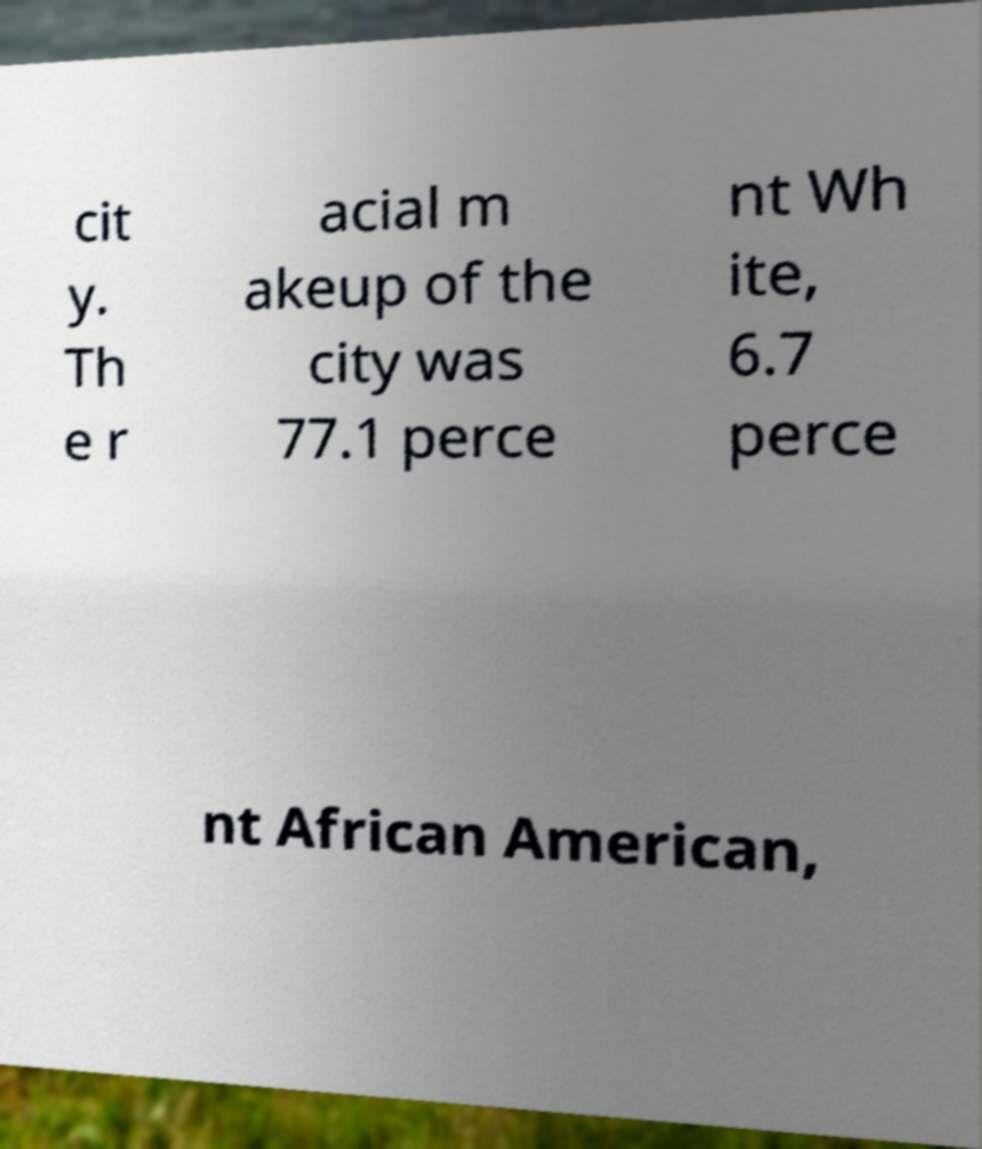What messages or text are displayed in this image? I need them in a readable, typed format. cit y. Th e r acial m akeup of the city was 77.1 perce nt Wh ite, 6.7 perce nt African American, 